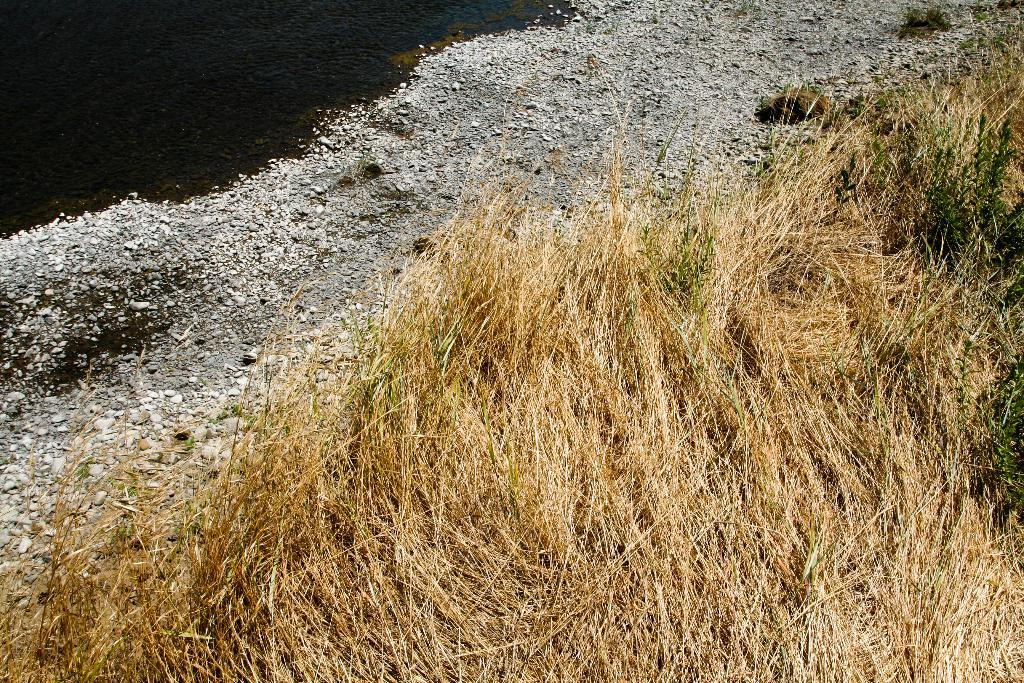What type of vegetation can be seen in the image? There is dried grass in the image. What other objects can be seen in the image? There are stones visible in the image. What natural element is present in the image? Water is visible in the image. Can you tell me how many chess pieces are on the railway in the image? There is no railway or chess pieces present in the image. What type of straw is used to create a barrier around the dried grass in the image? There is no straw present in the image; it only features dried grass and stones. 